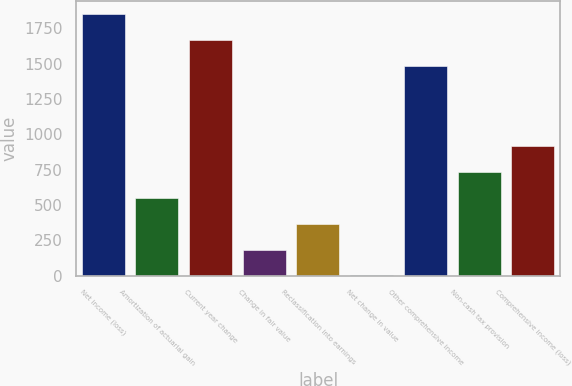<chart> <loc_0><loc_0><loc_500><loc_500><bar_chart><fcel>Net income (loss)<fcel>Amortization of actuarial gain<fcel>Current year change<fcel>Change in fair value<fcel>Reclassification into earnings<fcel>Net change in value<fcel>Other comprehensive income<fcel>Non-cash tax provision<fcel>Comprehensive income (loss)<nl><fcel>1852.6<fcel>550.9<fcel>1669.3<fcel>184.3<fcel>367.6<fcel>1<fcel>1486<fcel>734.2<fcel>917.5<nl></chart> 